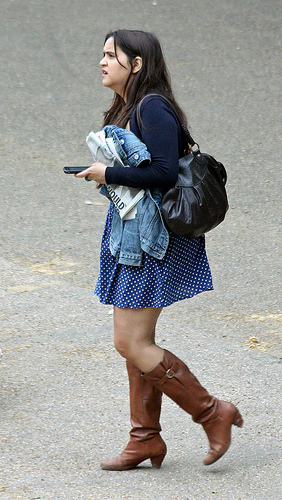Can you guess what the person might be doing or where they might be heading? The individual is holding what appears to be a mobile device and newspapers, which might suggest that they are heading to work or university and are possibly catching up on news or tasks while on the move.  Based on what the person is carrying and wearing, what might their profession or occupation be? It's not advisable to assume a person's profession based on appearance, but the combination of casual attire and the presence of newspapers could hint at a profession that values staying updated with current events, such as journalism, academia, or a business-related field. 